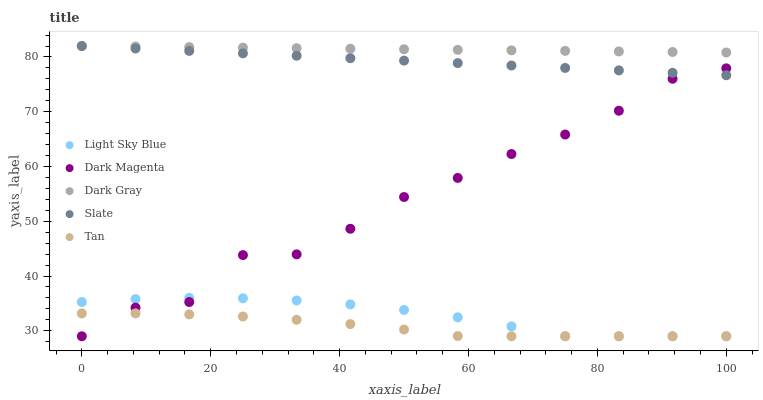Does Tan have the minimum area under the curve?
Answer yes or no. Yes. Does Dark Gray have the maximum area under the curve?
Answer yes or no. Yes. Does Slate have the minimum area under the curve?
Answer yes or no. No. Does Slate have the maximum area under the curve?
Answer yes or no. No. Is Slate the smoothest?
Answer yes or no. Yes. Is Dark Magenta the roughest?
Answer yes or no. Yes. Is Light Sky Blue the smoothest?
Answer yes or no. No. Is Light Sky Blue the roughest?
Answer yes or no. No. Does Light Sky Blue have the lowest value?
Answer yes or no. Yes. Does Slate have the lowest value?
Answer yes or no. No. Does Slate have the highest value?
Answer yes or no. Yes. Does Light Sky Blue have the highest value?
Answer yes or no. No. Is Dark Magenta less than Dark Gray?
Answer yes or no. Yes. Is Dark Gray greater than Dark Magenta?
Answer yes or no. Yes. Does Light Sky Blue intersect Dark Magenta?
Answer yes or no. Yes. Is Light Sky Blue less than Dark Magenta?
Answer yes or no. No. Is Light Sky Blue greater than Dark Magenta?
Answer yes or no. No. Does Dark Magenta intersect Dark Gray?
Answer yes or no. No. 